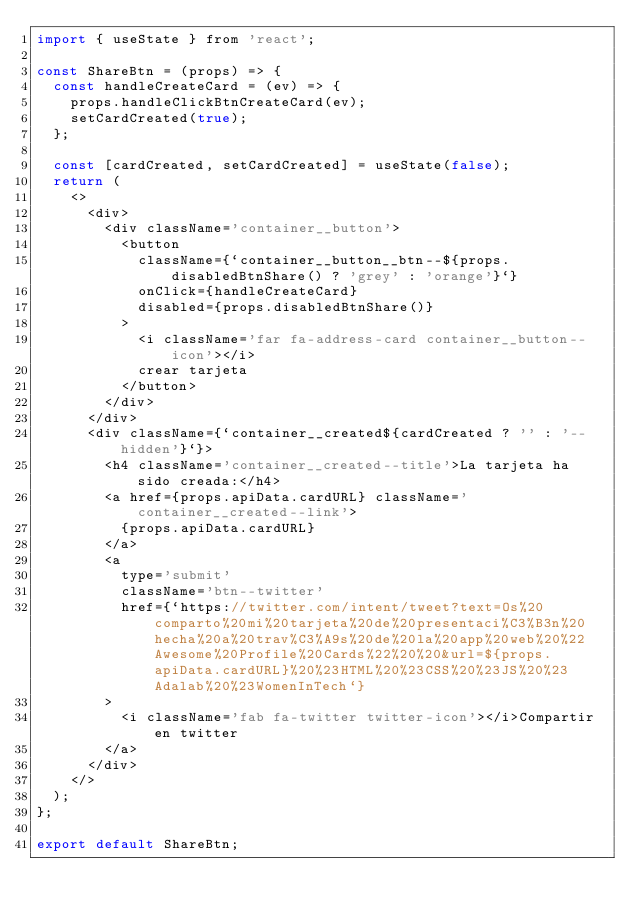Convert code to text. <code><loc_0><loc_0><loc_500><loc_500><_JavaScript_>import { useState } from 'react';

const ShareBtn = (props) => {
  const handleCreateCard = (ev) => {
    props.handleClickBtnCreateCard(ev);
    setCardCreated(true);
  };

  const [cardCreated, setCardCreated] = useState(false);
  return (
    <>
      <div>
        <div className='container__button'>
          <button
            className={`container__button__btn--${props.disabledBtnShare() ? 'grey' : 'orange'}`}
            onClick={handleCreateCard}
            disabled={props.disabledBtnShare()}
          >
            <i className='far fa-address-card container__button--icon'></i>
            crear tarjeta
          </button>
        </div>
      </div>
      <div className={`container__created${cardCreated ? '' : '--hidden'}`}>
        <h4 className='container__created--title'>La tarjeta ha sido creada:</h4>
        <a href={props.apiData.cardURL} className='container__created--link'>
          {props.apiData.cardURL}
        </a>
        <a
          type='submit'
          className='btn--twitter'
          href={`https://twitter.com/intent/tweet?text=Os%20comparto%20mi%20tarjeta%20de%20presentaci%C3%B3n%20hecha%20a%20trav%C3%A9s%20de%20la%20app%20web%20%22Awesome%20Profile%20Cards%22%20%20&url=${props.apiData.cardURL}%20%23HTML%20%23CSS%20%23JS%20%23Adalab%20%23WomenInTech`}
        >
          <i className='fab fa-twitter twitter-icon'></i>Compartir en twitter
        </a>
      </div>
    </>
  );
};

export default ShareBtn;
</code> 